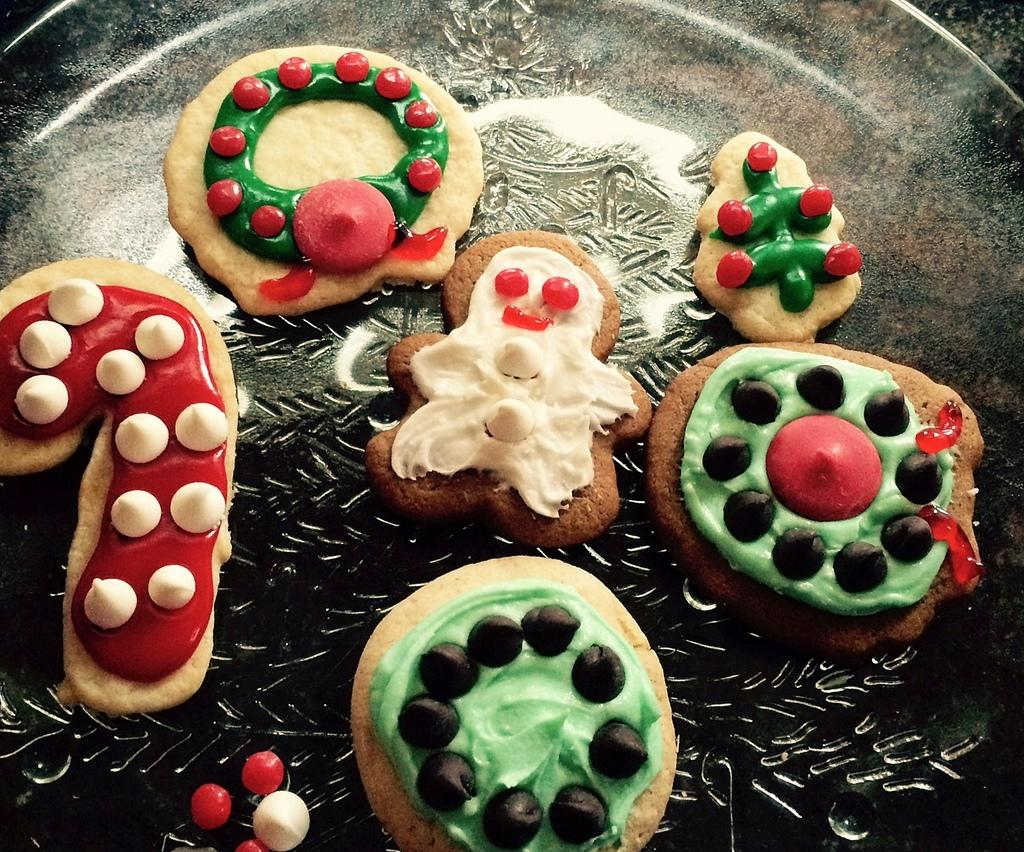What type of food can be seen in the image? There are cookies on a surface in the image. Can you describe the arrangement of the cookies? The cookies are placed on a surface, but the specific arrangement cannot be determined from the image. What might someone do with the cookies in the image? Someone might eat the cookies or use them for decoration. What type of smoke can be seen coming from the cookies in the image? There is no smoke present in the image; it only features cookies on a surface. 